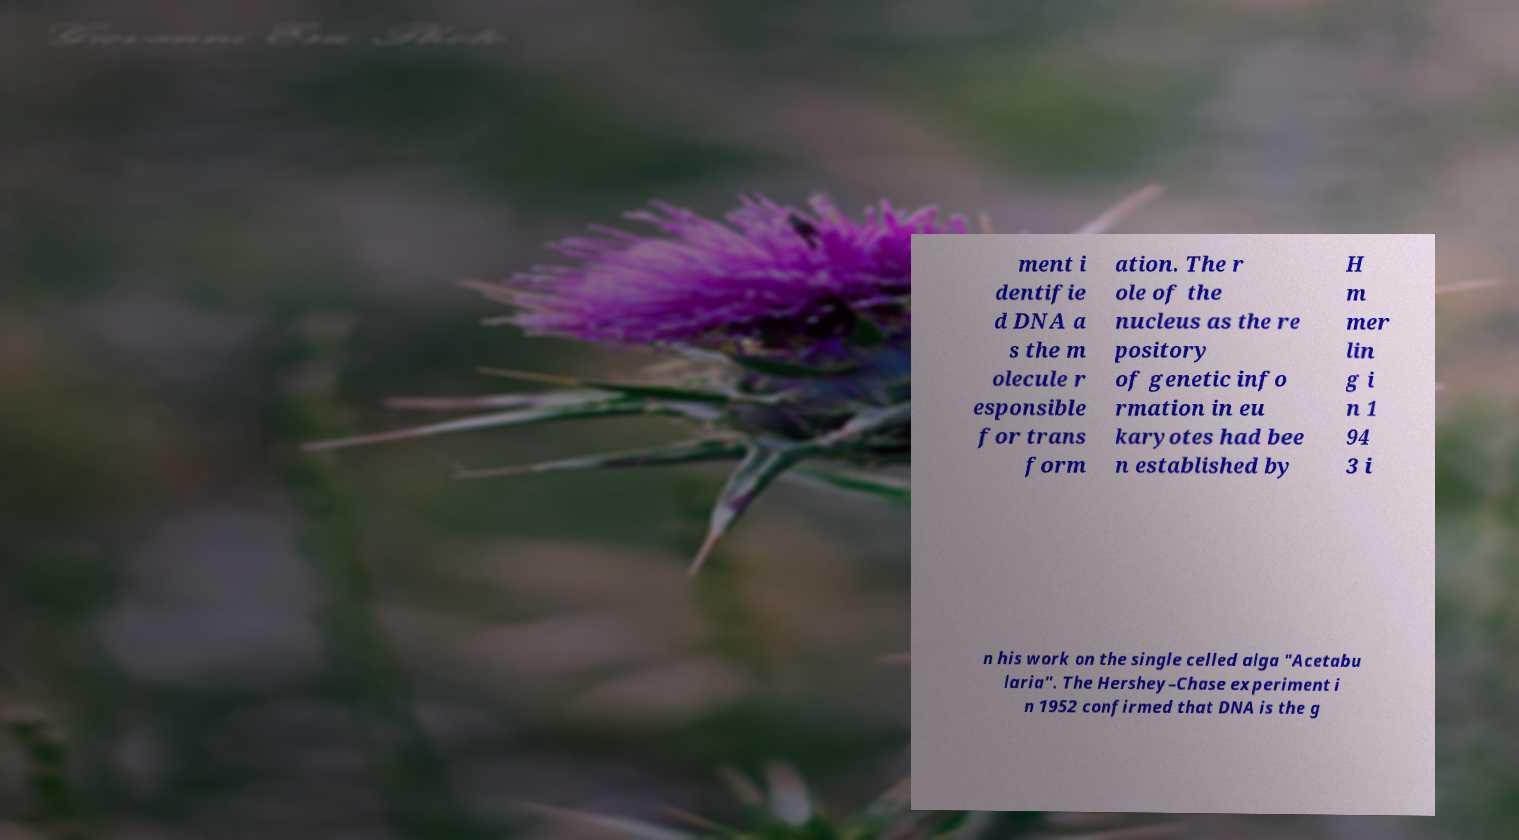I need the written content from this picture converted into text. Can you do that? ment i dentifie d DNA a s the m olecule r esponsible for trans form ation. The r ole of the nucleus as the re pository of genetic info rmation in eu karyotes had bee n established by H m mer lin g i n 1 94 3 i n his work on the single celled alga "Acetabu laria". The Hershey–Chase experiment i n 1952 confirmed that DNA is the g 